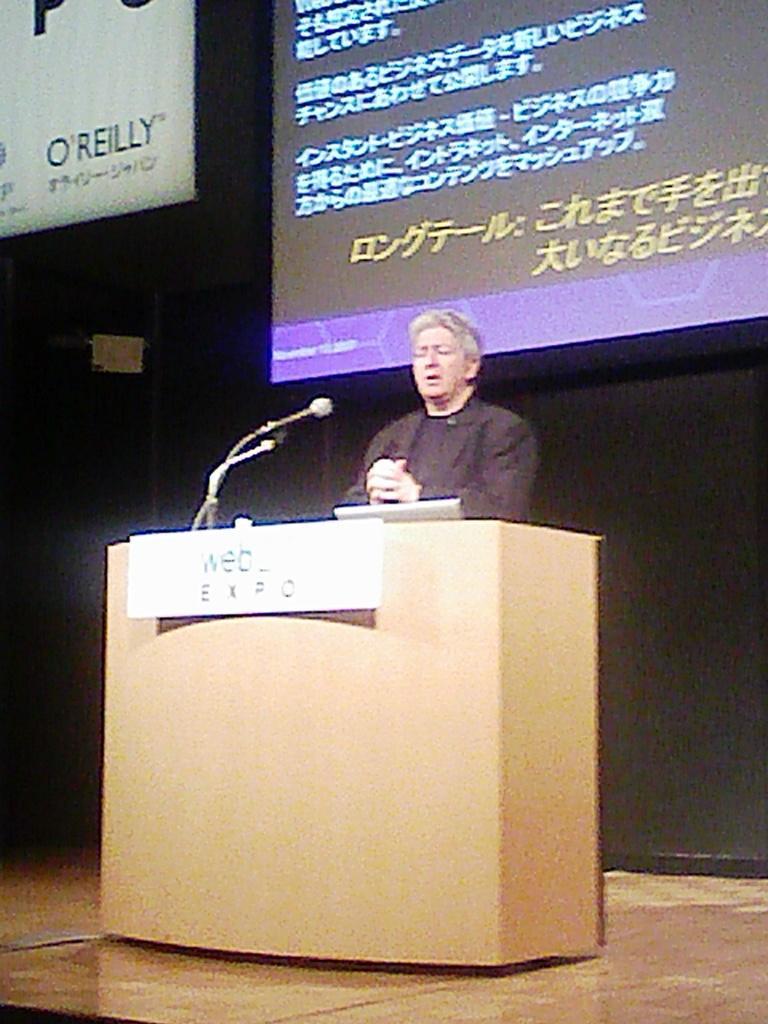Can you describe this image briefly? This picture seems to be clicked inside the hall. In the center we can see a person standing behind a podium and we can see the text on the board attached to the podium and we can see the microphone and some other objects. In the background we can see the text on the banner and the text on the projector screen and we can see some other objects. 